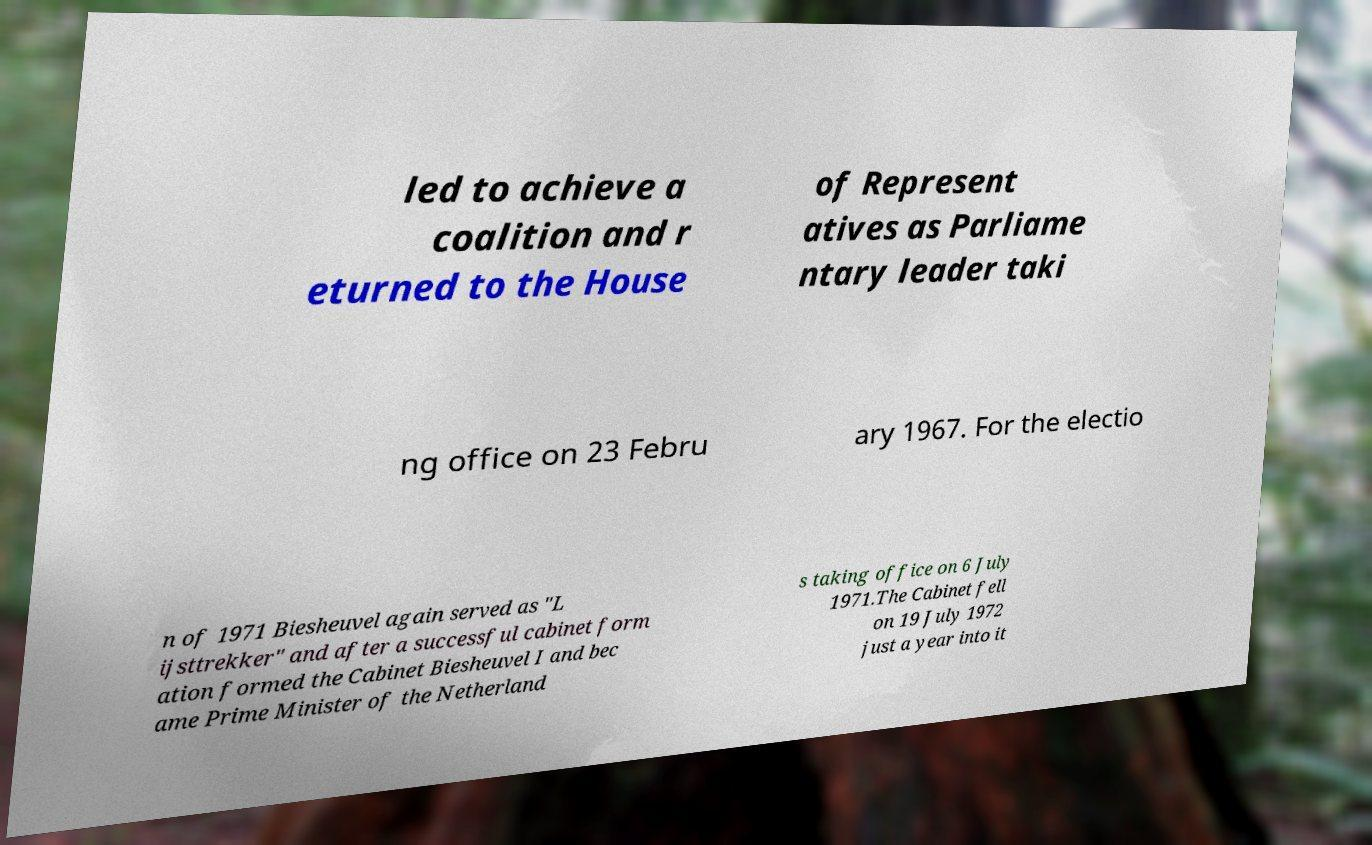For documentation purposes, I need the text within this image transcribed. Could you provide that? led to achieve a coalition and r eturned to the House of Represent atives as Parliame ntary leader taki ng office on 23 Febru ary 1967. For the electio n of 1971 Biesheuvel again served as "L ijsttrekker" and after a successful cabinet form ation formed the Cabinet Biesheuvel I and bec ame Prime Minister of the Netherland s taking office on 6 July 1971.The Cabinet fell on 19 July 1972 just a year into it 